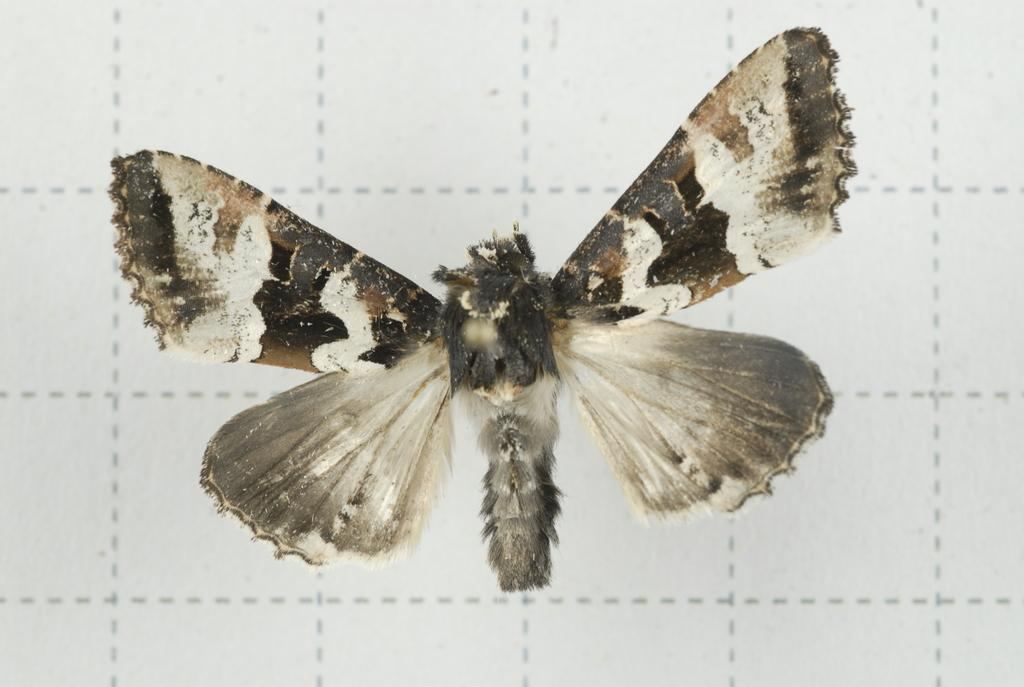What type of insect is in the image? There is a white color butterfly in the image. Where is the butterfly located in the image? The butterfly is in the front of the image. What is the background of the image? There is a white paper background in the image. What type of airport is visible in the image? There is no airport present in the image; it features a white color butterfly on a white paper background. 